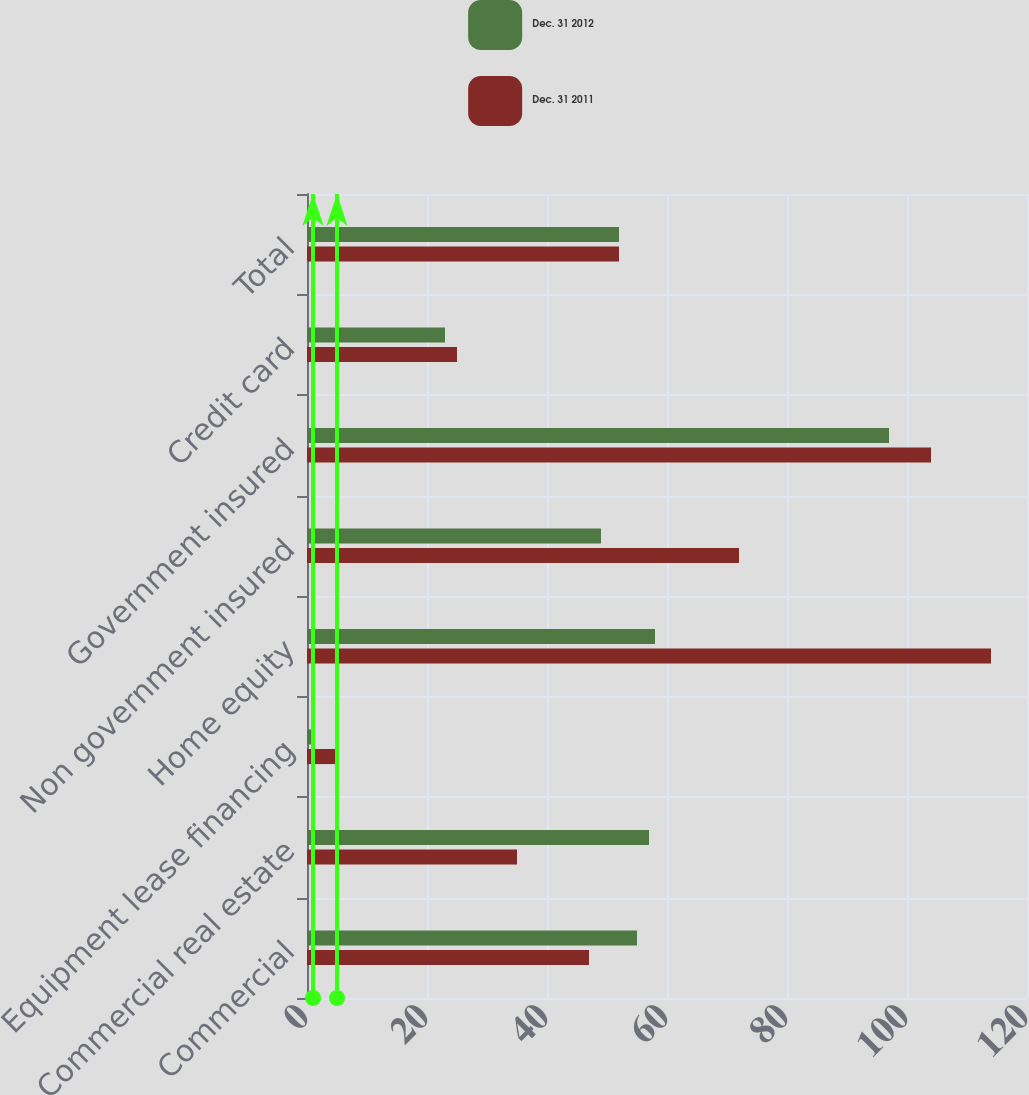Convert chart to OTSL. <chart><loc_0><loc_0><loc_500><loc_500><stacked_bar_chart><ecel><fcel>Commercial<fcel>Commercial real estate<fcel>Equipment lease financing<fcel>Home equity<fcel>Non government insured<fcel>Government insured<fcel>Credit card<fcel>Total<nl><fcel>Dec. 31 2012<fcel>55<fcel>57<fcel>1<fcel>58<fcel>49<fcel>97<fcel>23<fcel>52<nl><fcel>Dec. 31 2011<fcel>47<fcel>35<fcel>5<fcel>114<fcel>72<fcel>104<fcel>25<fcel>52<nl></chart> 